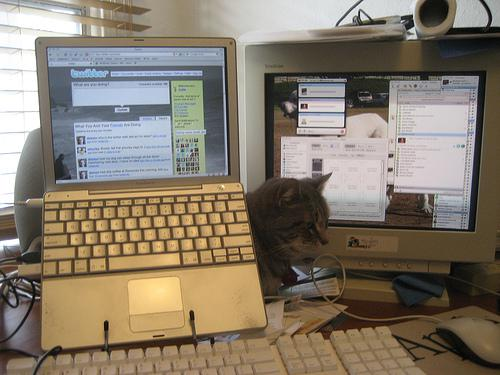Question: what is the focus?
Choices:
A. Dog running outside.
B. Man eating dinner.
C. Computer screen.
D. Cat laying between computers.
Answer with the letter. Answer: D Question: what animal is shown?
Choices:
A. Cat.
B. Bird.
C. Horse.
D. Goat.
Answer with the letter. Answer: A Question: where was this taken?
Choices:
A. School.
B. Office.
C. Bedroom.
D. Field.
Answer with the letter. Answer: B Question: how many cats are in the picture?
Choices:
A. 2.
B. 1.
C. 3.
D. 4.
Answer with the letter. Answer: B 